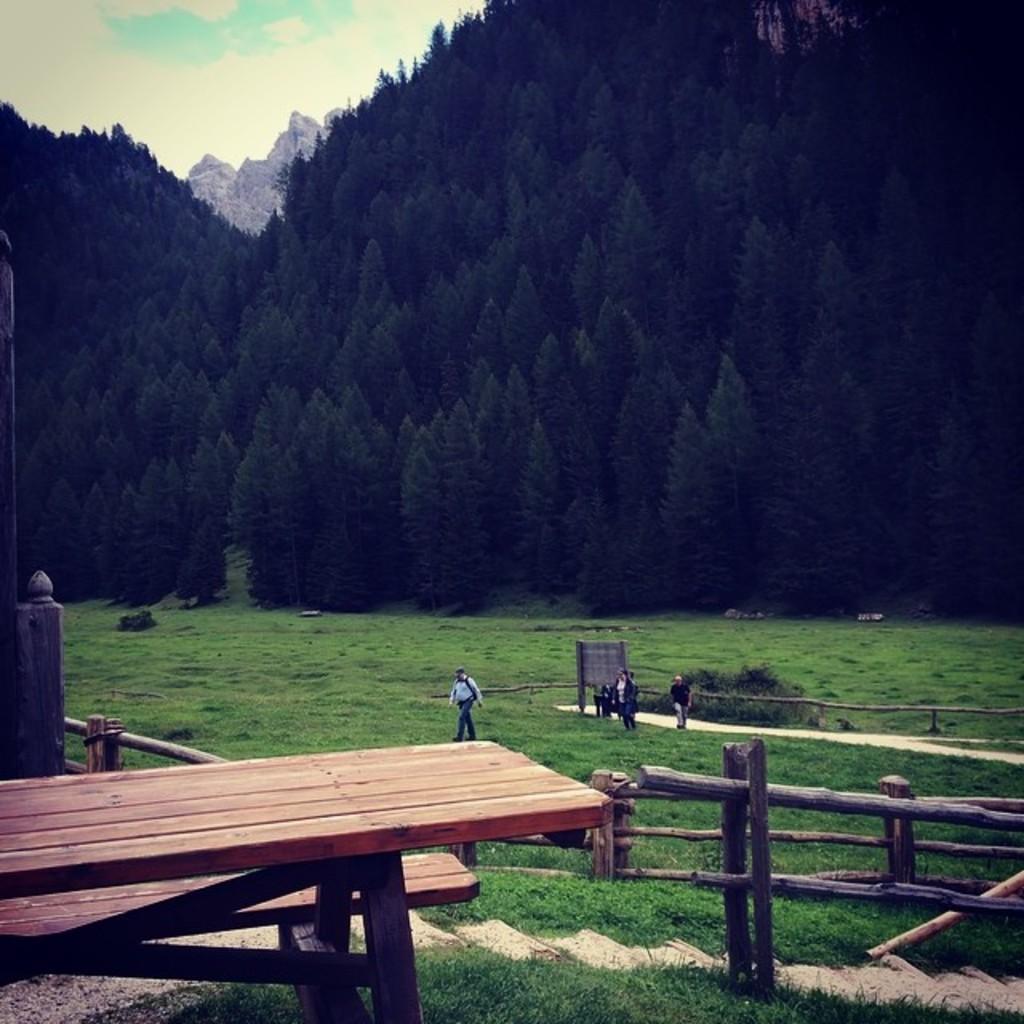Could you give a brief overview of what you see in this image? This is an outside view. At the bottom of the image I can see a bench, fencing and the grass on the land. There are few people walking on the ground. In the background, I can see the trees and hills. On the top of the image I can see the sky. 